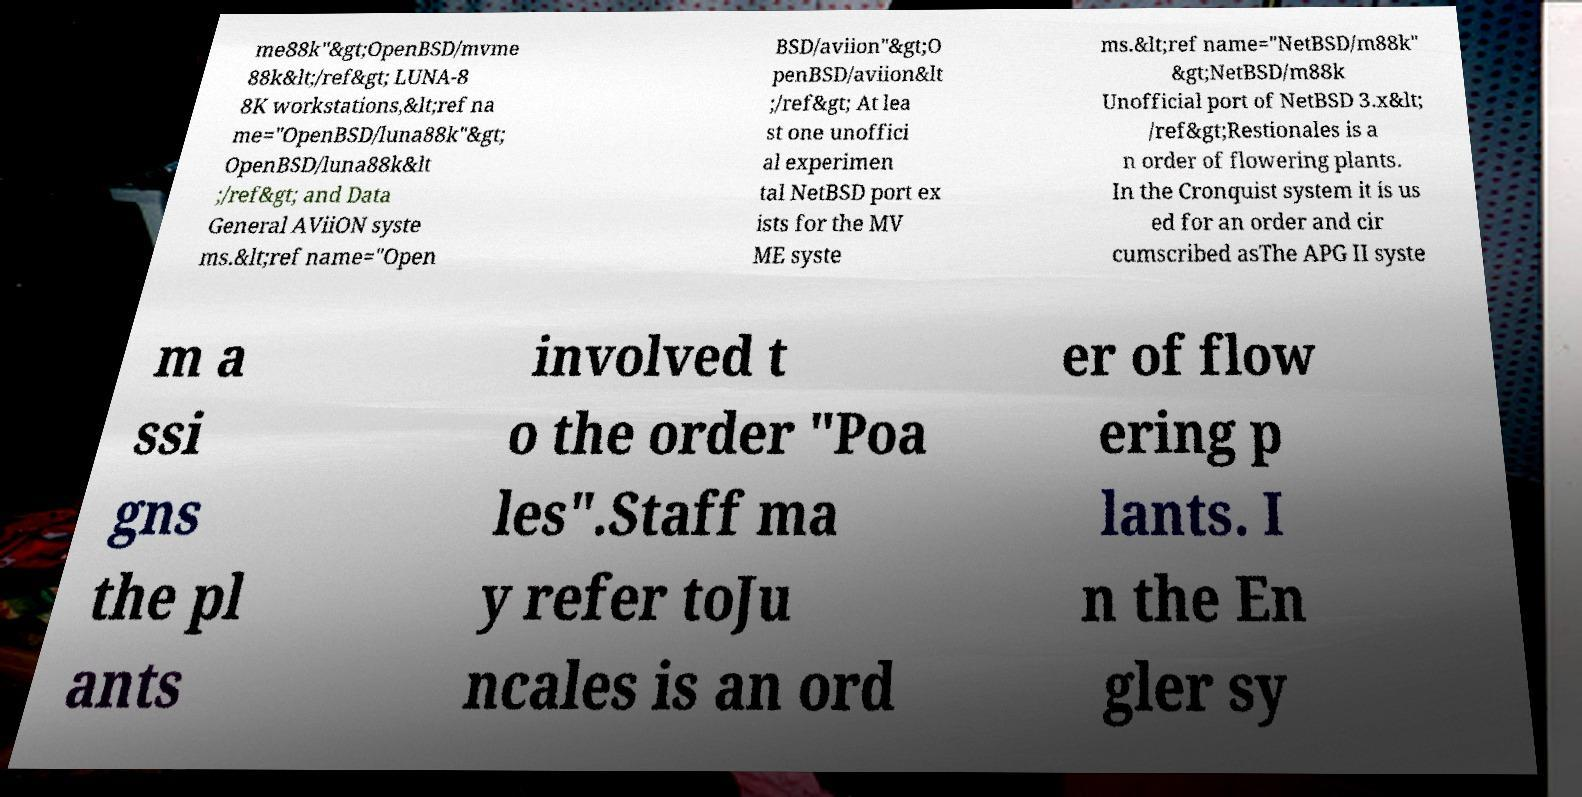Please read and relay the text visible in this image. What does it say? me88k"&gt;OpenBSD/mvme 88k&lt;/ref&gt; LUNA-8 8K workstations,&lt;ref na me="OpenBSD/luna88k"&gt; OpenBSD/luna88k&lt ;/ref&gt; and Data General AViiON syste ms.&lt;ref name="Open BSD/aviion"&gt;O penBSD/aviion&lt ;/ref&gt; At lea st one unoffici al experimen tal NetBSD port ex ists for the MV ME syste ms.&lt;ref name="NetBSD/m88k" &gt;NetBSD/m88k Unofficial port of NetBSD 3.x&lt; /ref&gt;Restionales is a n order of flowering plants. In the Cronquist system it is us ed for an order and cir cumscribed asThe APG II syste m a ssi gns the pl ants involved t o the order "Poa les".Staff ma y refer toJu ncales is an ord er of flow ering p lants. I n the En gler sy 